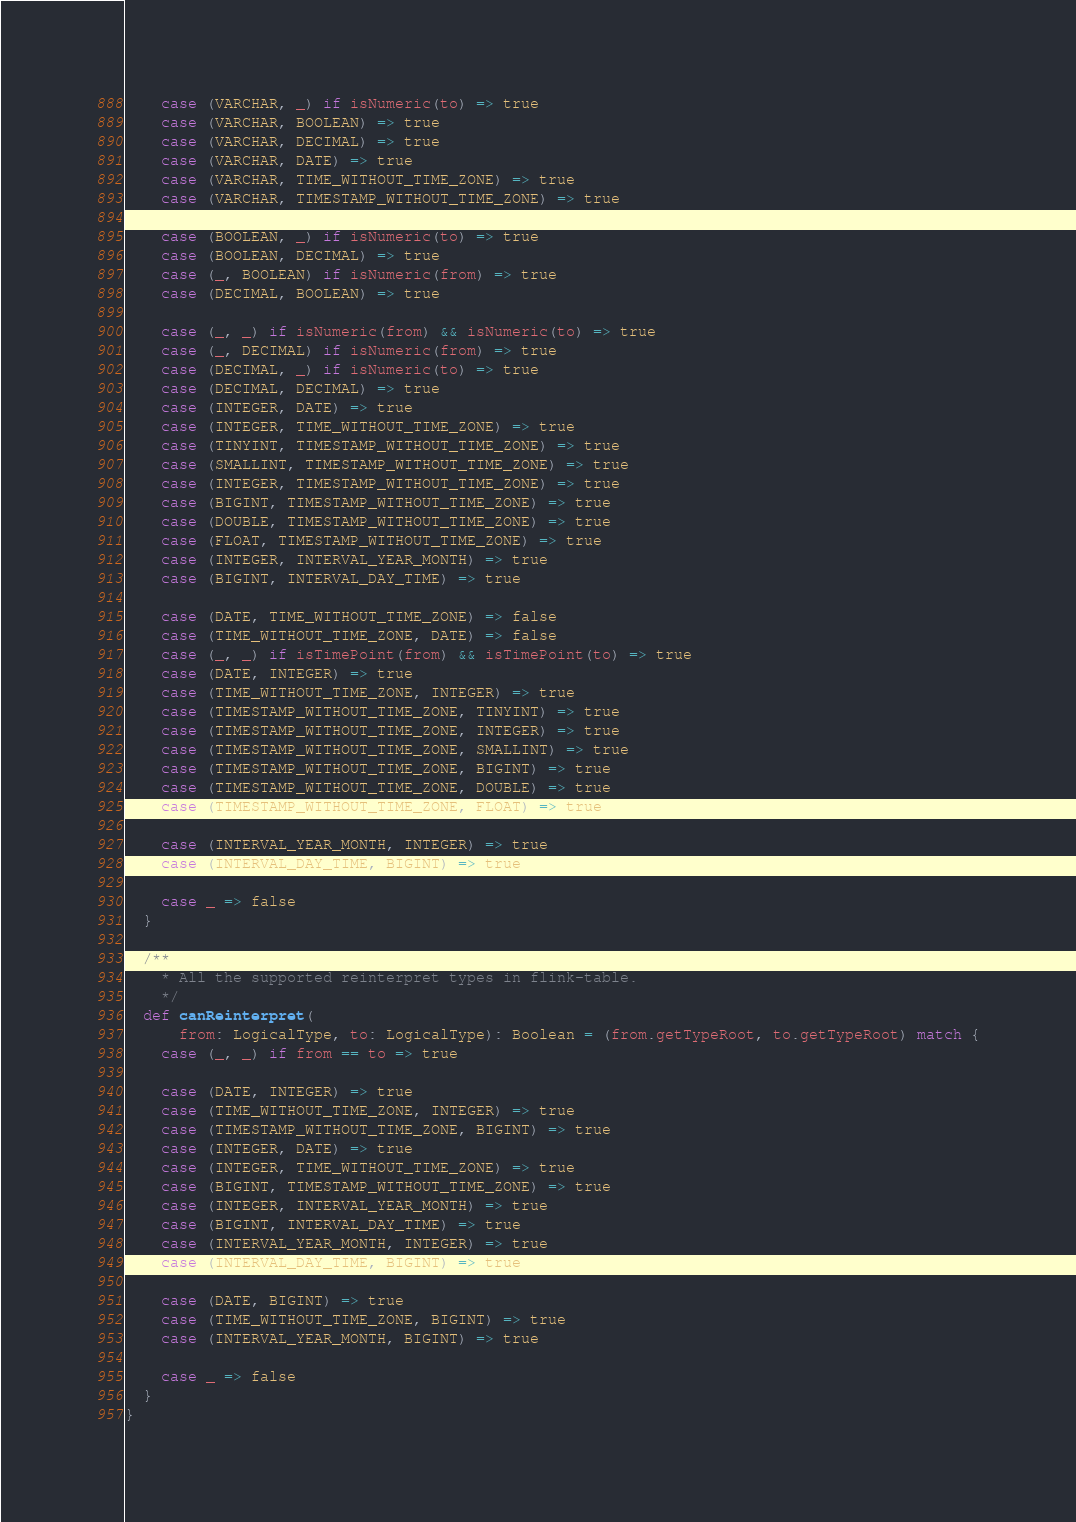<code> <loc_0><loc_0><loc_500><loc_500><_Scala_>    case (VARCHAR, _) if isNumeric(to) => true
    case (VARCHAR, BOOLEAN) => true
    case (VARCHAR, DECIMAL) => true
    case (VARCHAR, DATE) => true
    case (VARCHAR, TIME_WITHOUT_TIME_ZONE) => true
    case (VARCHAR, TIMESTAMP_WITHOUT_TIME_ZONE) => true

    case (BOOLEAN, _) if isNumeric(to) => true
    case (BOOLEAN, DECIMAL) => true
    case (_, BOOLEAN) if isNumeric(from) => true
    case (DECIMAL, BOOLEAN) => true

    case (_, _) if isNumeric(from) && isNumeric(to) => true
    case (_, DECIMAL) if isNumeric(from) => true
    case (DECIMAL, _) if isNumeric(to) => true
    case (DECIMAL, DECIMAL) => true
    case (INTEGER, DATE) => true
    case (INTEGER, TIME_WITHOUT_TIME_ZONE) => true
    case (TINYINT, TIMESTAMP_WITHOUT_TIME_ZONE) => true
    case (SMALLINT, TIMESTAMP_WITHOUT_TIME_ZONE) => true
    case (INTEGER, TIMESTAMP_WITHOUT_TIME_ZONE) => true
    case (BIGINT, TIMESTAMP_WITHOUT_TIME_ZONE) => true
    case (DOUBLE, TIMESTAMP_WITHOUT_TIME_ZONE) => true
    case (FLOAT, TIMESTAMP_WITHOUT_TIME_ZONE) => true
    case (INTEGER, INTERVAL_YEAR_MONTH) => true
    case (BIGINT, INTERVAL_DAY_TIME) => true

    case (DATE, TIME_WITHOUT_TIME_ZONE) => false
    case (TIME_WITHOUT_TIME_ZONE, DATE) => false
    case (_, _) if isTimePoint(from) && isTimePoint(to) => true
    case (DATE, INTEGER) => true
    case (TIME_WITHOUT_TIME_ZONE, INTEGER) => true
    case (TIMESTAMP_WITHOUT_TIME_ZONE, TINYINT) => true
    case (TIMESTAMP_WITHOUT_TIME_ZONE, INTEGER) => true
    case (TIMESTAMP_WITHOUT_TIME_ZONE, SMALLINT) => true
    case (TIMESTAMP_WITHOUT_TIME_ZONE, BIGINT) => true
    case (TIMESTAMP_WITHOUT_TIME_ZONE, DOUBLE) => true
    case (TIMESTAMP_WITHOUT_TIME_ZONE, FLOAT) => true

    case (INTERVAL_YEAR_MONTH, INTEGER) => true
    case (INTERVAL_DAY_TIME, BIGINT) => true

    case _ => false
  }

  /**
    * All the supported reinterpret types in flink-table.
    */
  def canReinterpret(
      from: LogicalType, to: LogicalType): Boolean = (from.getTypeRoot, to.getTypeRoot) match {
    case (_, _) if from == to => true

    case (DATE, INTEGER) => true
    case (TIME_WITHOUT_TIME_ZONE, INTEGER) => true
    case (TIMESTAMP_WITHOUT_TIME_ZONE, BIGINT) => true
    case (INTEGER, DATE) => true
    case (INTEGER, TIME_WITHOUT_TIME_ZONE) => true
    case (BIGINT, TIMESTAMP_WITHOUT_TIME_ZONE) => true
    case (INTEGER, INTERVAL_YEAR_MONTH) => true
    case (BIGINT, INTERVAL_DAY_TIME) => true
    case (INTERVAL_YEAR_MONTH, INTEGER) => true
    case (INTERVAL_DAY_TIME, BIGINT) => true

    case (DATE, BIGINT) => true
    case (TIME_WITHOUT_TIME_ZONE, BIGINT) => true
    case (INTERVAL_YEAR_MONTH, BIGINT) => true

    case _ => false
  }
}
</code> 